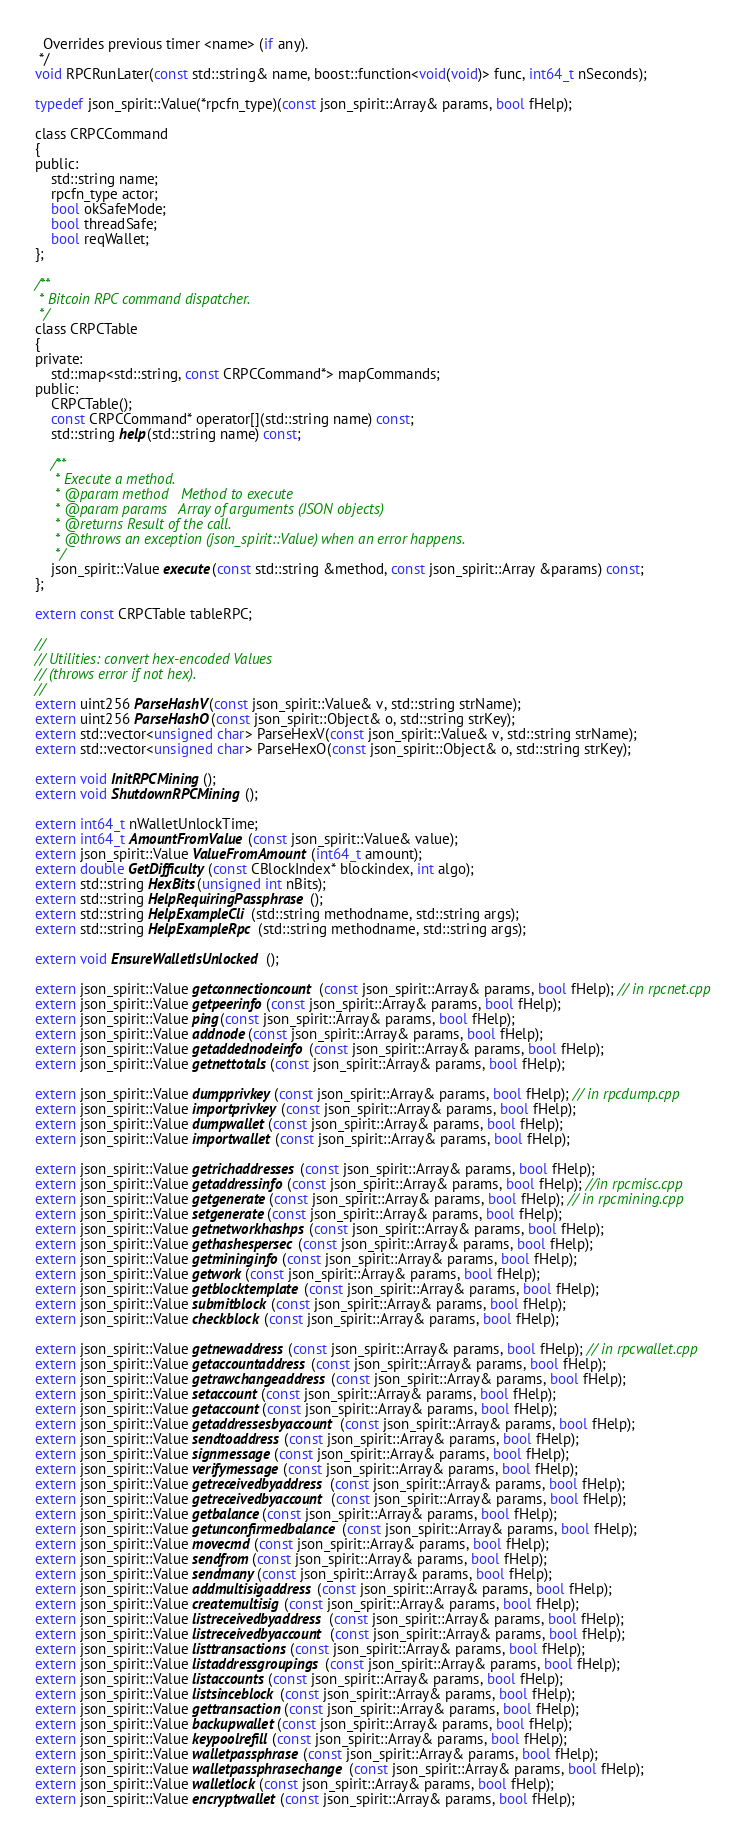<code> <loc_0><loc_0><loc_500><loc_500><_C_>  Overrides previous timer <name> (if any).
 */
void RPCRunLater(const std::string& name, boost::function<void(void)> func, int64_t nSeconds);

typedef json_spirit::Value(*rpcfn_type)(const json_spirit::Array& params, bool fHelp);

class CRPCCommand
{
public:
    std::string name;
    rpcfn_type actor;
    bool okSafeMode;
    bool threadSafe;
    bool reqWallet;
};

/**
 * Bitcoin RPC command dispatcher.
 */
class CRPCTable
{
private:
    std::map<std::string, const CRPCCommand*> mapCommands;
public:
    CRPCTable();
    const CRPCCommand* operator[](std::string name) const;
    std::string help(std::string name) const;

    /**
     * Execute a method.
     * @param method   Method to execute
     * @param params   Array of arguments (JSON objects)
     * @returns Result of the call.
     * @throws an exception (json_spirit::Value) when an error happens.
     */
    json_spirit::Value execute(const std::string &method, const json_spirit::Array &params) const;
};

extern const CRPCTable tableRPC;

//
// Utilities: convert hex-encoded Values
// (throws error if not hex).
//
extern uint256 ParseHashV(const json_spirit::Value& v, std::string strName);
extern uint256 ParseHashO(const json_spirit::Object& o, std::string strKey);
extern std::vector<unsigned char> ParseHexV(const json_spirit::Value& v, std::string strName);
extern std::vector<unsigned char> ParseHexO(const json_spirit::Object& o, std::string strKey);

extern void InitRPCMining();
extern void ShutdownRPCMining();

extern int64_t nWalletUnlockTime;
extern int64_t AmountFromValue(const json_spirit::Value& value);
extern json_spirit::Value ValueFromAmount(int64_t amount);
extern double GetDifficulty(const CBlockIndex* blockindex, int algo);
extern std::string HexBits(unsigned int nBits);
extern std::string HelpRequiringPassphrase();
extern std::string HelpExampleCli(std::string methodname, std::string args);
extern std::string HelpExampleRpc(std::string methodname, std::string args);

extern void EnsureWalletIsUnlocked();

extern json_spirit::Value getconnectioncount(const json_spirit::Array& params, bool fHelp); // in rpcnet.cpp
extern json_spirit::Value getpeerinfo(const json_spirit::Array& params, bool fHelp);
extern json_spirit::Value ping(const json_spirit::Array& params, bool fHelp);
extern json_spirit::Value addnode(const json_spirit::Array& params, bool fHelp);
extern json_spirit::Value getaddednodeinfo(const json_spirit::Array& params, bool fHelp);
extern json_spirit::Value getnettotals(const json_spirit::Array& params, bool fHelp);

extern json_spirit::Value dumpprivkey(const json_spirit::Array& params, bool fHelp); // in rpcdump.cpp
extern json_spirit::Value importprivkey(const json_spirit::Array& params, bool fHelp);
extern json_spirit::Value dumpwallet(const json_spirit::Array& params, bool fHelp);
extern json_spirit::Value importwallet(const json_spirit::Array& params, bool fHelp);

extern json_spirit::Value getrichaddresses(const json_spirit::Array& params, bool fHelp);
extern json_spirit::Value getaddressinfo(const json_spirit::Array& params, bool fHelp); //in rpcmisc.cpp
extern json_spirit::Value getgenerate(const json_spirit::Array& params, bool fHelp); // in rpcmining.cpp
extern json_spirit::Value setgenerate(const json_spirit::Array& params, bool fHelp);
extern json_spirit::Value getnetworkhashps(const json_spirit::Array& params, bool fHelp);
extern json_spirit::Value gethashespersec(const json_spirit::Array& params, bool fHelp);
extern json_spirit::Value getmininginfo(const json_spirit::Array& params, bool fHelp);
extern json_spirit::Value getwork(const json_spirit::Array& params, bool fHelp);
extern json_spirit::Value getblocktemplate(const json_spirit::Array& params, bool fHelp);
extern json_spirit::Value submitblock(const json_spirit::Array& params, bool fHelp);
extern json_spirit::Value checkblock(const json_spirit::Array& params, bool fHelp);

extern json_spirit::Value getnewaddress(const json_spirit::Array& params, bool fHelp); // in rpcwallet.cpp
extern json_spirit::Value getaccountaddress(const json_spirit::Array& params, bool fHelp);
extern json_spirit::Value getrawchangeaddress(const json_spirit::Array& params, bool fHelp);
extern json_spirit::Value setaccount(const json_spirit::Array& params, bool fHelp);
extern json_spirit::Value getaccount(const json_spirit::Array& params, bool fHelp);
extern json_spirit::Value getaddressesbyaccount(const json_spirit::Array& params, bool fHelp);
extern json_spirit::Value sendtoaddress(const json_spirit::Array& params, bool fHelp);
extern json_spirit::Value signmessage(const json_spirit::Array& params, bool fHelp);
extern json_spirit::Value verifymessage(const json_spirit::Array& params, bool fHelp);
extern json_spirit::Value getreceivedbyaddress(const json_spirit::Array& params, bool fHelp);
extern json_spirit::Value getreceivedbyaccount(const json_spirit::Array& params, bool fHelp);
extern json_spirit::Value getbalance(const json_spirit::Array& params, bool fHelp);
extern json_spirit::Value getunconfirmedbalance(const json_spirit::Array& params, bool fHelp);
extern json_spirit::Value movecmd(const json_spirit::Array& params, bool fHelp);
extern json_spirit::Value sendfrom(const json_spirit::Array& params, bool fHelp);
extern json_spirit::Value sendmany(const json_spirit::Array& params, bool fHelp);
extern json_spirit::Value addmultisigaddress(const json_spirit::Array& params, bool fHelp);
extern json_spirit::Value createmultisig(const json_spirit::Array& params, bool fHelp);
extern json_spirit::Value listreceivedbyaddress(const json_spirit::Array& params, bool fHelp);
extern json_spirit::Value listreceivedbyaccount(const json_spirit::Array& params, bool fHelp);
extern json_spirit::Value listtransactions(const json_spirit::Array& params, bool fHelp);
extern json_spirit::Value listaddressgroupings(const json_spirit::Array& params, bool fHelp);
extern json_spirit::Value listaccounts(const json_spirit::Array& params, bool fHelp);
extern json_spirit::Value listsinceblock(const json_spirit::Array& params, bool fHelp);
extern json_spirit::Value gettransaction(const json_spirit::Array& params, bool fHelp);
extern json_spirit::Value backupwallet(const json_spirit::Array& params, bool fHelp);
extern json_spirit::Value keypoolrefill(const json_spirit::Array& params, bool fHelp);
extern json_spirit::Value walletpassphrase(const json_spirit::Array& params, bool fHelp);
extern json_spirit::Value walletpassphrasechange(const json_spirit::Array& params, bool fHelp);
extern json_spirit::Value walletlock(const json_spirit::Array& params, bool fHelp);
extern json_spirit::Value encryptwallet(const json_spirit::Array& params, bool fHelp);</code> 